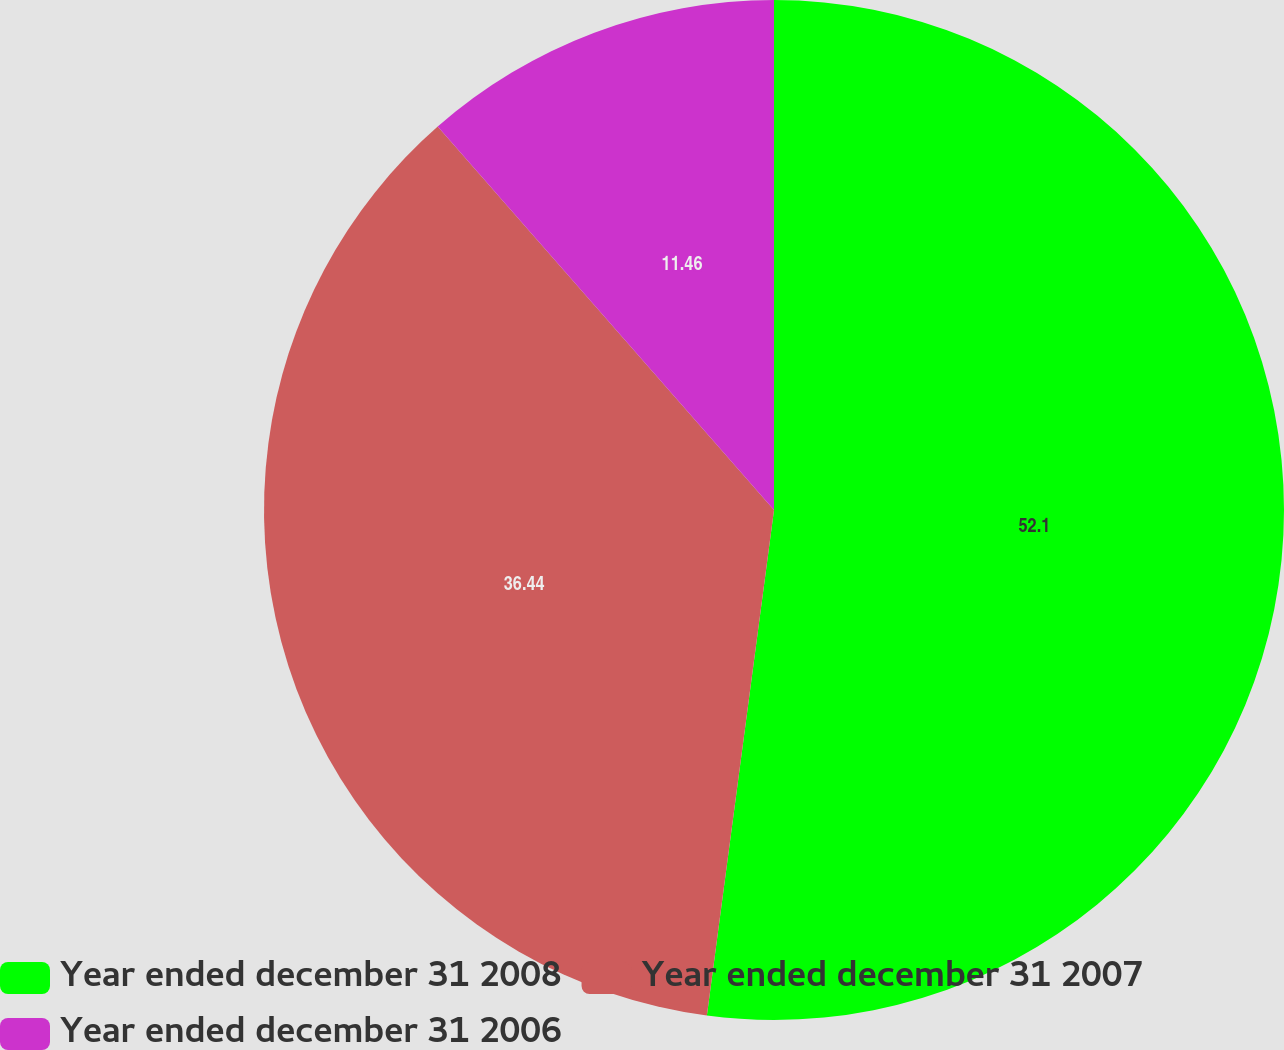<chart> <loc_0><loc_0><loc_500><loc_500><pie_chart><fcel>Year ended december 31 2008<fcel>Year ended december 31 2007<fcel>Year ended december 31 2006<nl><fcel>52.1%<fcel>36.44%<fcel>11.46%<nl></chart> 